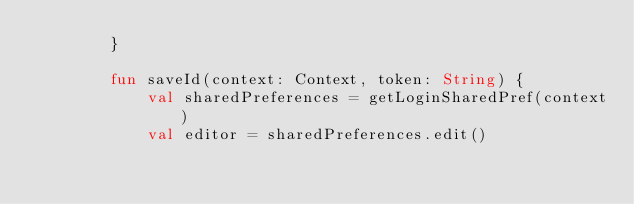Convert code to text. <code><loc_0><loc_0><loc_500><loc_500><_Kotlin_>        }

        fun saveId(context: Context, token: String) {
            val sharedPreferences = getLoginSharedPref(context)
            val editor = sharedPreferences.edit()</code> 